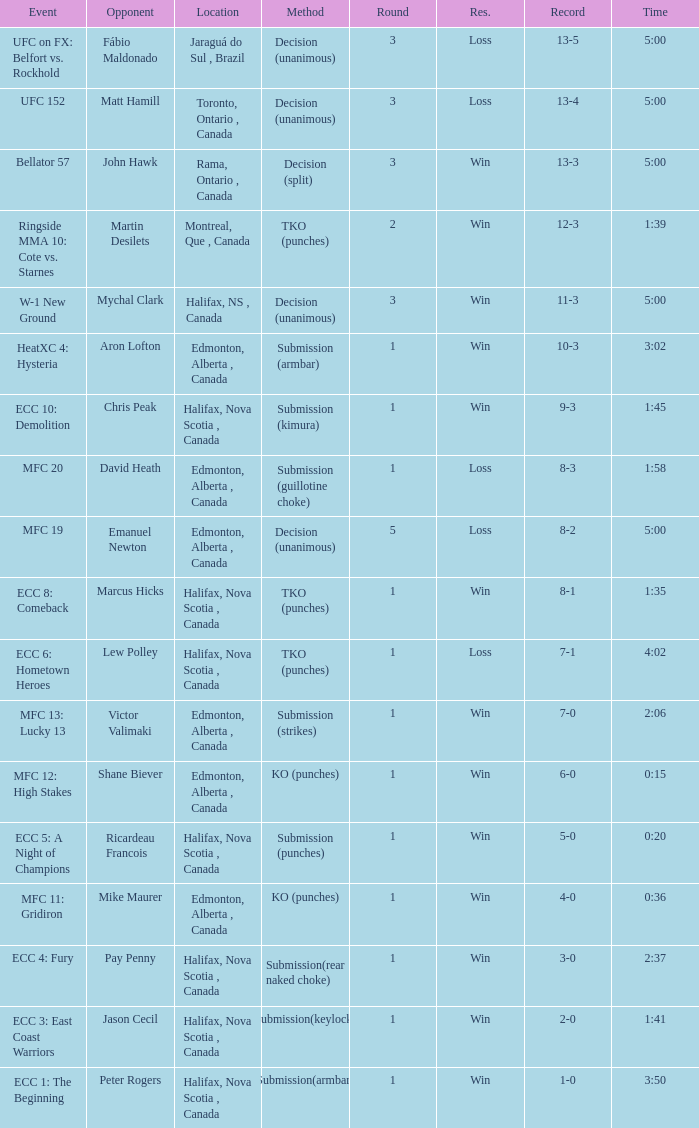What is the method of the match with 1 round and a time of 1:58? Submission (guillotine choke). 